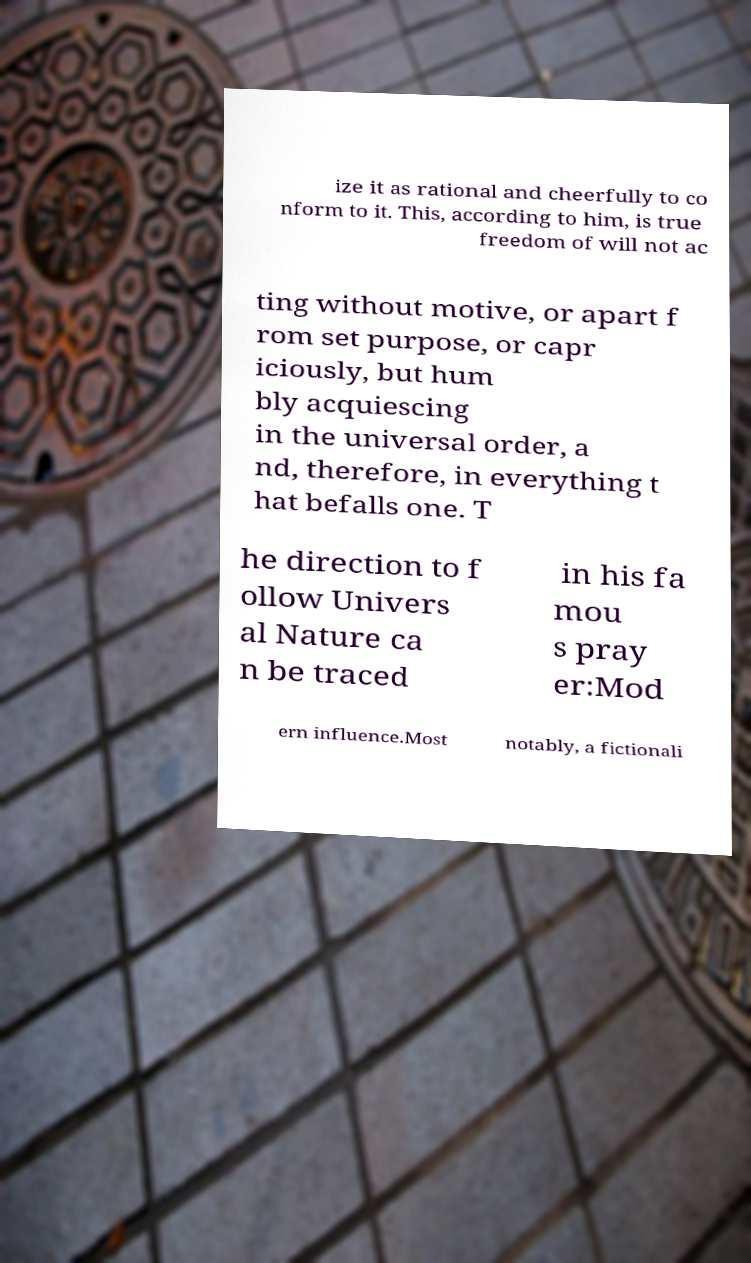Could you assist in decoding the text presented in this image and type it out clearly? ize it as rational and cheerfully to co nform to it. This, according to him, is true freedom of will not ac ting without motive, or apart f rom set purpose, or capr iciously, but hum bly acquiescing in the universal order, a nd, therefore, in everything t hat befalls one. T he direction to f ollow Univers al Nature ca n be traced in his fa mou s pray er:Mod ern influence.Most notably, a fictionali 